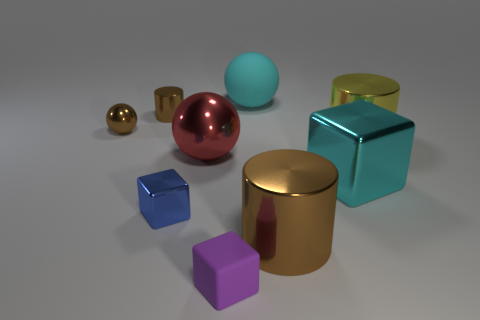How many large cubes have the same material as the blue thing?
Provide a succinct answer. 1. Are there fewer brown metallic spheres that are in front of the red ball than tiny brown spheres?
Keep it short and to the point. Yes. There is a brown metal cylinder that is left of the brown object in front of the small blue shiny block; what size is it?
Your answer should be compact. Small. There is a rubber cube; does it have the same color as the large sphere right of the big red thing?
Offer a terse response. No. There is a red thing that is the same size as the yellow metal thing; what material is it?
Give a very brief answer. Metal. Are there fewer big cylinders that are in front of the large brown metal cylinder than large yellow things that are left of the small brown shiny ball?
Your answer should be compact. No. The large cyan thing right of the brown cylinder that is right of the small blue cube is what shape?
Provide a short and direct response. Cube. Is there a large cyan matte ball?
Your answer should be compact. Yes. There is a shiny ball on the right side of the small brown sphere; what color is it?
Provide a succinct answer. Red. There is a thing that is the same color as the large matte ball; what is its material?
Your response must be concise. Metal. 